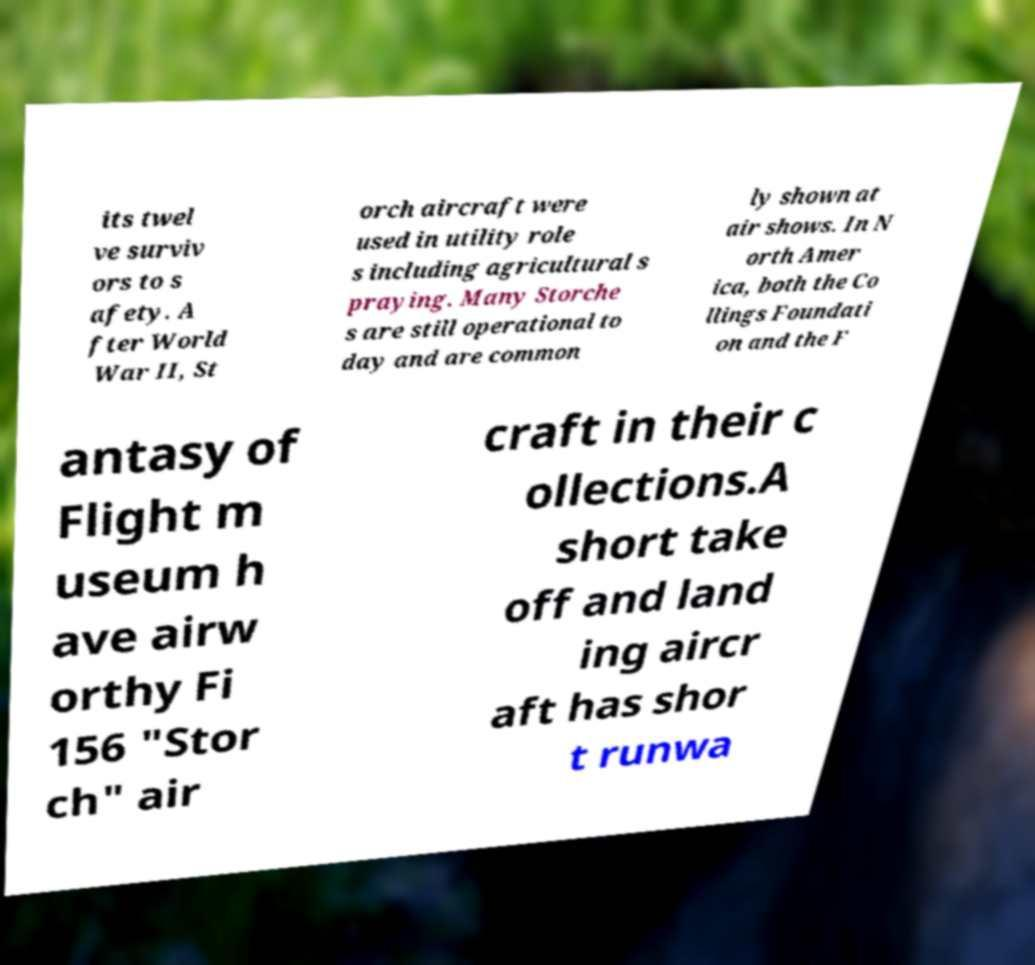Could you extract and type out the text from this image? its twel ve surviv ors to s afety. A fter World War II, St orch aircraft were used in utility role s including agricultural s praying. Many Storche s are still operational to day and are common ly shown at air shows. In N orth Amer ica, both the Co llings Foundati on and the F antasy of Flight m useum h ave airw orthy Fi 156 "Stor ch" air craft in their c ollections.A short take off and land ing aircr aft has shor t runwa 